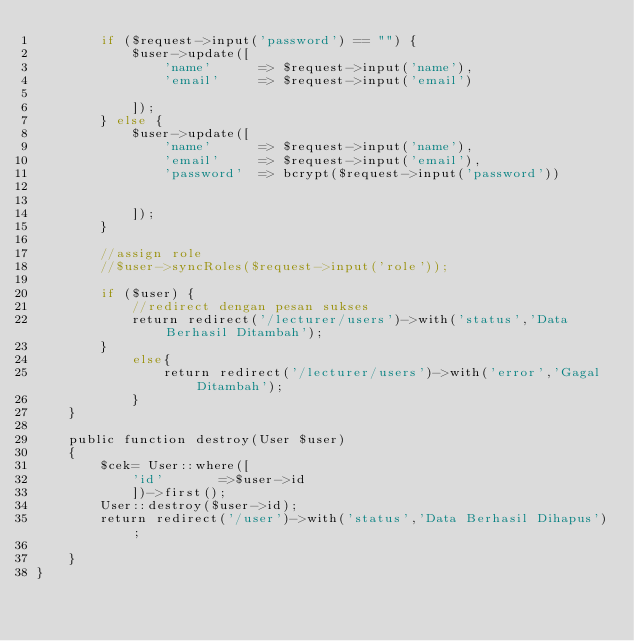Convert code to text. <code><loc_0><loc_0><loc_500><loc_500><_PHP_>        if ($request->input('password') == "") {
            $user->update([
                'name'      => $request->input('name'),
                'email'     => $request->input('email')
               
            ]);
        } else {
            $user->update([
                'name'      => $request->input('name'),
                'email'     => $request->input('email'),
                'password'  => bcrypt($request->input('password'))
                

            ]);
        }

        //assign role
        //$user->syncRoles($request->input('role'));

        if ($user) {
            //redirect dengan pesan sukses
            return redirect('/lecturer/users')->with('status','Data Berhasil Ditambah');
        }
            else{
                return redirect('/lecturer/users')->with('error','Gagal Ditambah');
            }
    }

    public function destroy(User $user)
    {
        $cek= User::where([
            'id'       =>$user->id
            ])->first();
        User::destroy($user->id);
        return redirect('/user')->with('status','Data Berhasil Dihapus');
  
    }
}
</code> 